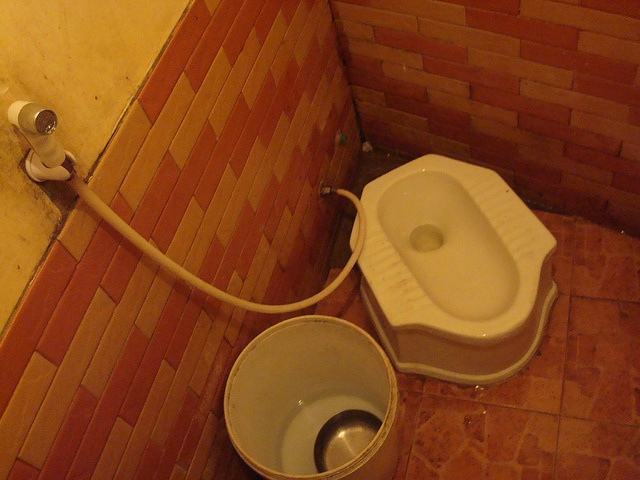Describe the objects in this image and their specific colors. I can see toilet in orange and olive tones and bowl in orange, olive, black, and maroon tones in this image. 